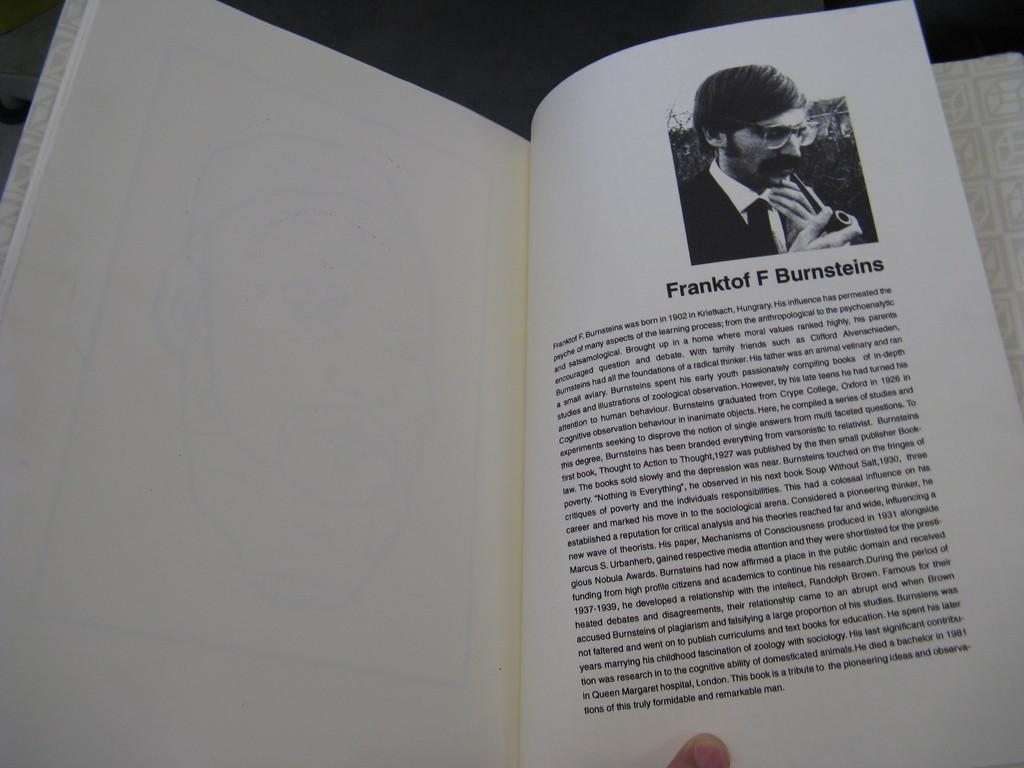Provide a one-sentence caption for the provided image. a page of a book with a picture of franktof f burnsteins. 